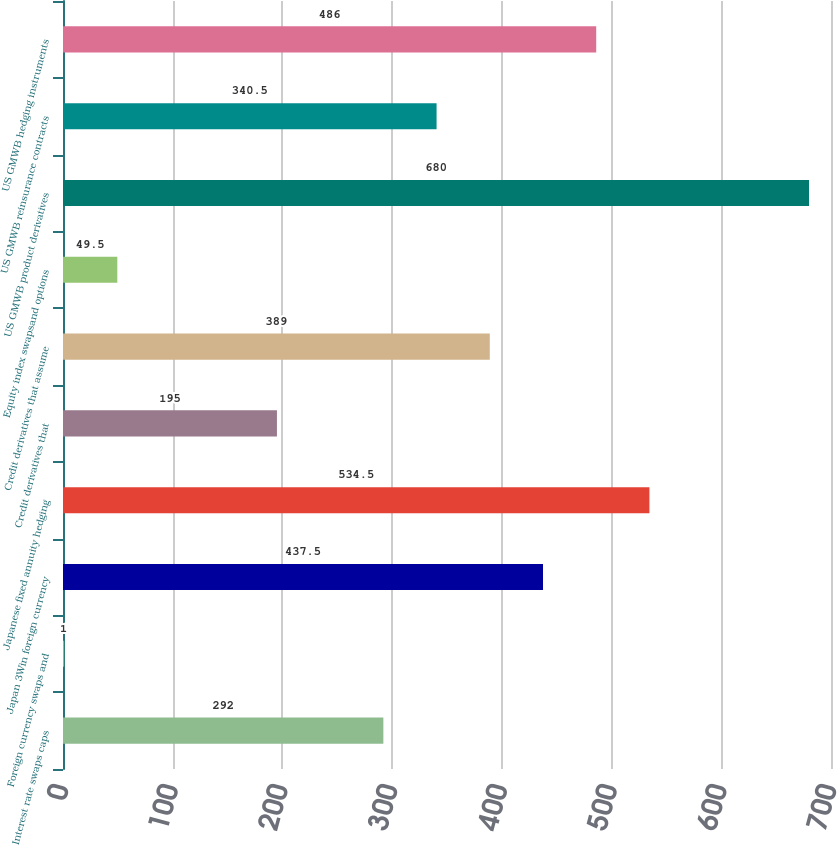Convert chart to OTSL. <chart><loc_0><loc_0><loc_500><loc_500><bar_chart><fcel>Interest rate swaps caps<fcel>Foreign currency swaps and<fcel>Japan 3Win foreign currency<fcel>Japanese fixed annuity hedging<fcel>Credit derivatives that<fcel>Credit derivatives that assume<fcel>Equity index swapsand options<fcel>US GMWB product derivatives<fcel>US GMWB reinsurance contracts<fcel>US GMWB hedging instruments<nl><fcel>292<fcel>1<fcel>437.5<fcel>534.5<fcel>195<fcel>389<fcel>49.5<fcel>680<fcel>340.5<fcel>486<nl></chart> 